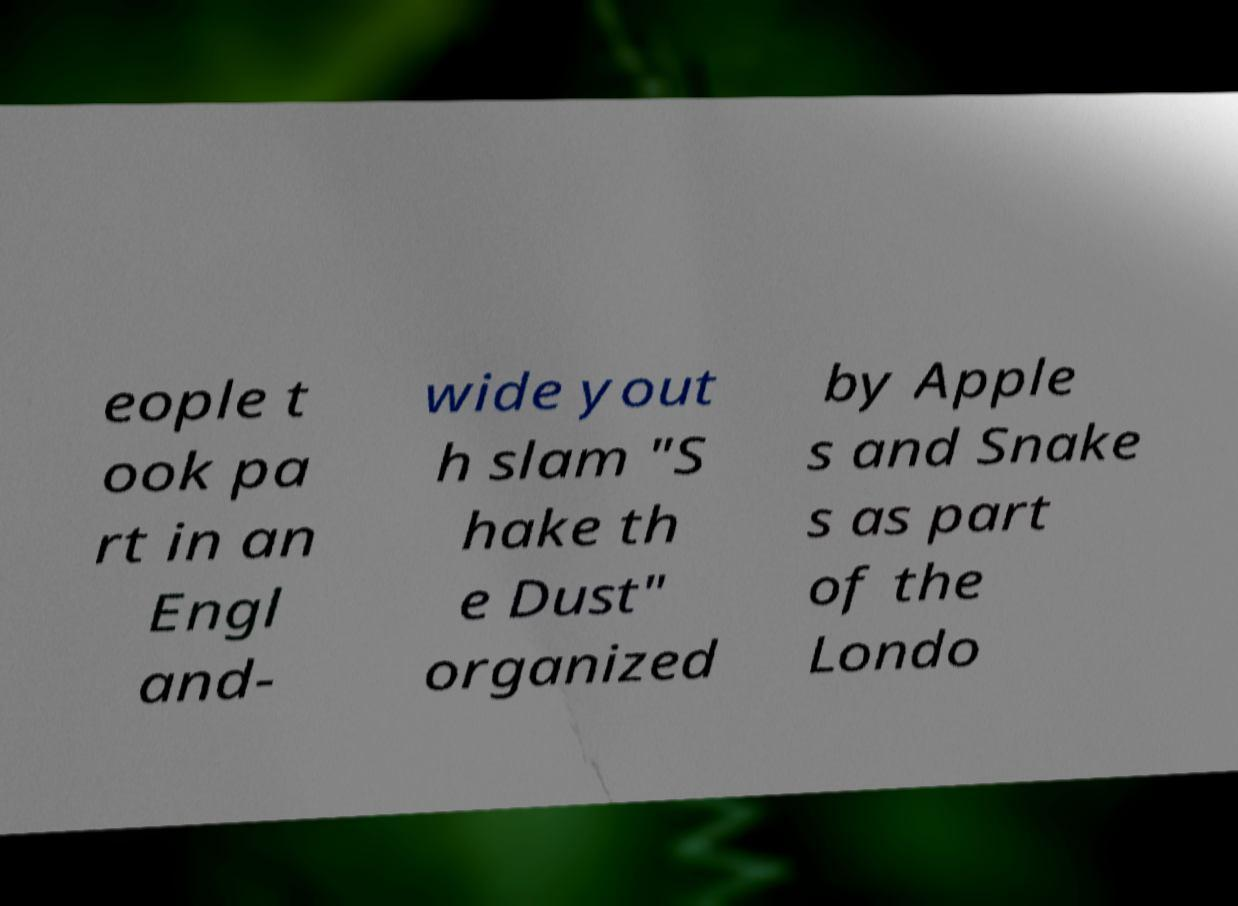Could you assist in decoding the text presented in this image and type it out clearly? eople t ook pa rt in an Engl and- wide yout h slam "S hake th e Dust" organized by Apple s and Snake s as part of the Londo 